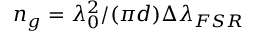Convert formula to latex. <formula><loc_0><loc_0><loc_500><loc_500>n _ { g } = \lambda _ { 0 } ^ { 2 } / ( { \pi } d ) { \Delta \lambda _ { F S R } }</formula> 